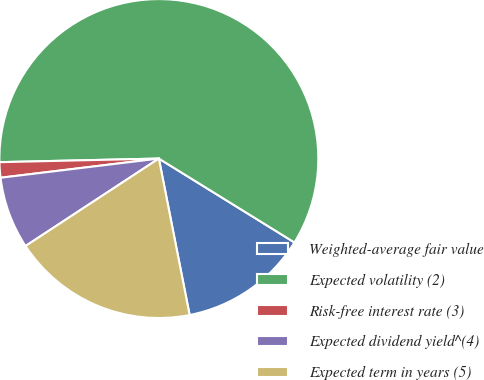<chart> <loc_0><loc_0><loc_500><loc_500><pie_chart><fcel>Weighted-average fair value<fcel>Expected volatility (2)<fcel>Risk-free interest rate (3)<fcel>Expected dividend yield^(4)<fcel>Expected term in years (5)<nl><fcel>13.09%<fcel>59.18%<fcel>1.56%<fcel>7.32%<fcel>18.85%<nl></chart> 